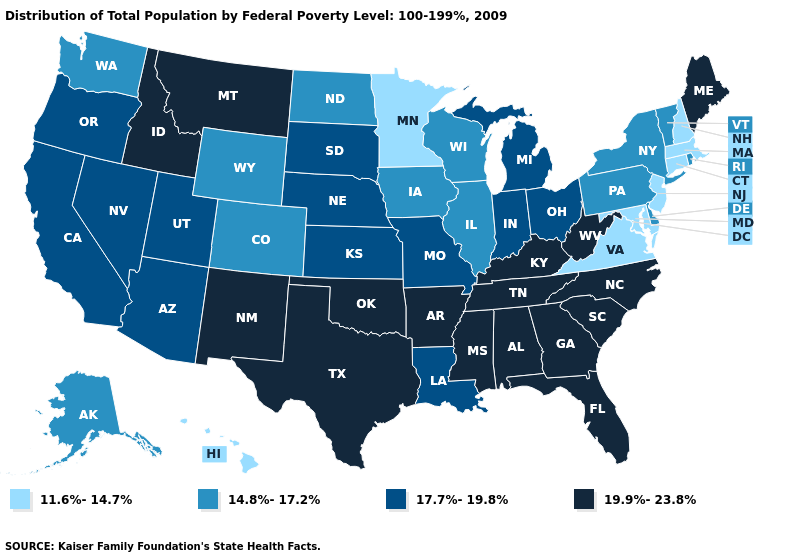What is the highest value in states that border Kansas?
Quick response, please. 19.9%-23.8%. Name the states that have a value in the range 14.8%-17.2%?
Be succinct. Alaska, Colorado, Delaware, Illinois, Iowa, New York, North Dakota, Pennsylvania, Rhode Island, Vermont, Washington, Wisconsin, Wyoming. Name the states that have a value in the range 19.9%-23.8%?
Concise answer only. Alabama, Arkansas, Florida, Georgia, Idaho, Kentucky, Maine, Mississippi, Montana, New Mexico, North Carolina, Oklahoma, South Carolina, Tennessee, Texas, West Virginia. What is the value of Oklahoma?
Keep it brief. 19.9%-23.8%. Name the states that have a value in the range 19.9%-23.8%?
Quick response, please. Alabama, Arkansas, Florida, Georgia, Idaho, Kentucky, Maine, Mississippi, Montana, New Mexico, North Carolina, Oklahoma, South Carolina, Tennessee, Texas, West Virginia. What is the value of Kansas?
Write a very short answer. 17.7%-19.8%. What is the lowest value in the South?
Quick response, please. 11.6%-14.7%. Name the states that have a value in the range 17.7%-19.8%?
Short answer required. Arizona, California, Indiana, Kansas, Louisiana, Michigan, Missouri, Nebraska, Nevada, Ohio, Oregon, South Dakota, Utah. What is the value of Wisconsin?
Quick response, please. 14.8%-17.2%. Name the states that have a value in the range 14.8%-17.2%?
Be succinct. Alaska, Colorado, Delaware, Illinois, Iowa, New York, North Dakota, Pennsylvania, Rhode Island, Vermont, Washington, Wisconsin, Wyoming. Among the states that border Pennsylvania , does Ohio have the highest value?
Give a very brief answer. No. What is the value of Kentucky?
Keep it brief. 19.9%-23.8%. Does Alabama have the highest value in the USA?
Give a very brief answer. Yes. Does Hawaii have the lowest value in the West?
Quick response, please. Yes. Name the states that have a value in the range 14.8%-17.2%?
Concise answer only. Alaska, Colorado, Delaware, Illinois, Iowa, New York, North Dakota, Pennsylvania, Rhode Island, Vermont, Washington, Wisconsin, Wyoming. 